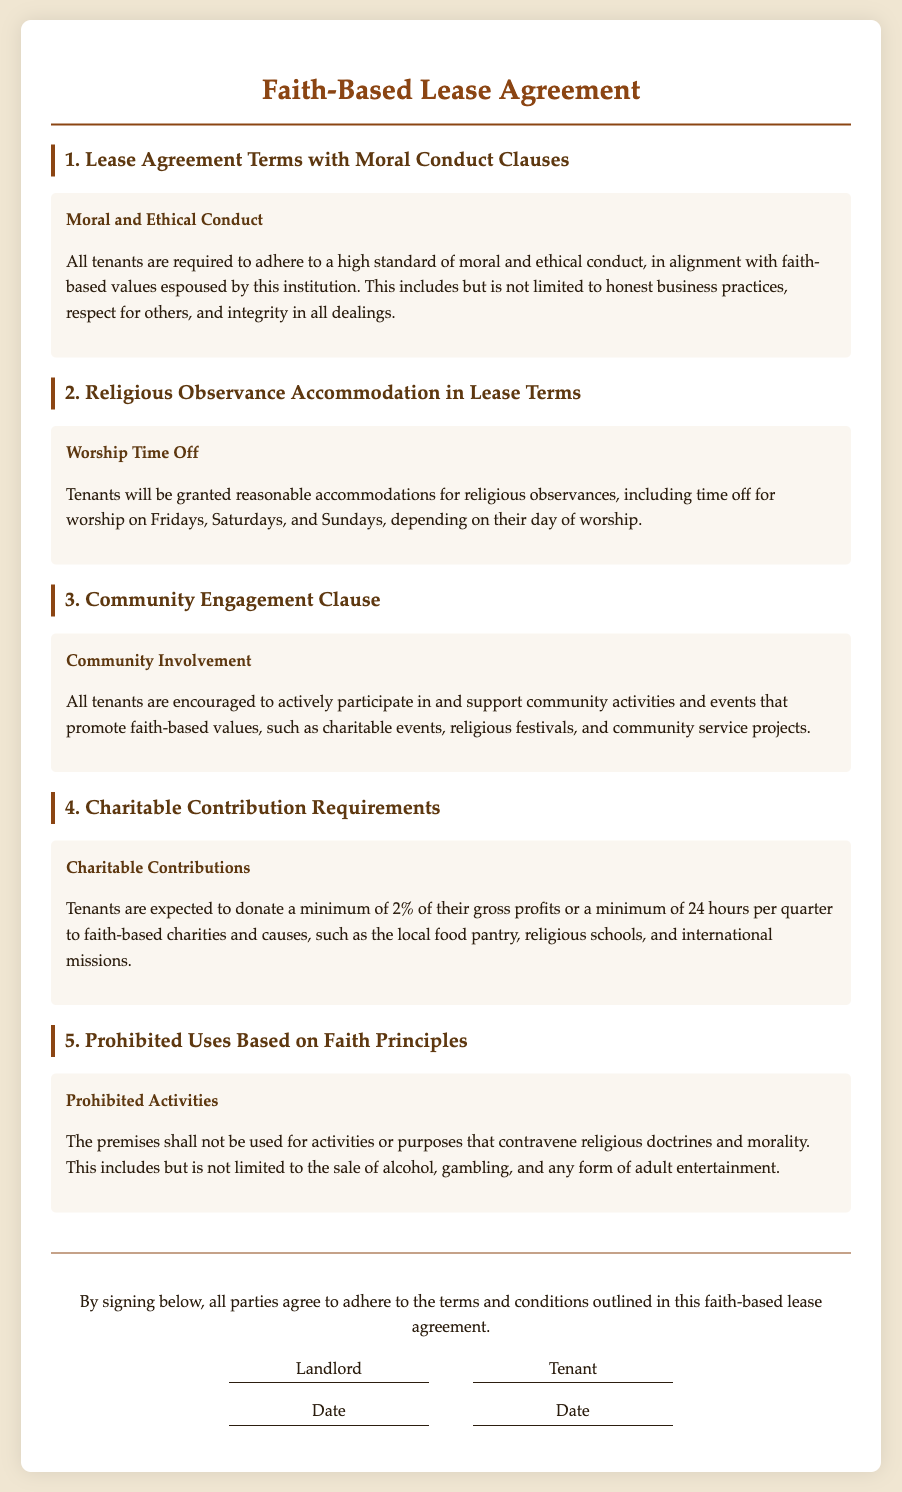What is the minimum donation percentage required from tenants? The document specifies that tenants are expected to donate a minimum of 2% of their gross profits or a minimum of 24 hours per quarter.
Answer: 2% What are the prohibited activities on the premises? The lease outlines that the premises shall not be used for activities that contravene religious doctrines and morality, which includes the sale of alcohol, gambling, and any form of adult entertainment.
Answer: Sale of alcohol, gambling, adult entertainment How many hours per quarter are tenants expected to contribute to charities? The document states that tenants must contribute a minimum of 24 hours per quarter to faith-based charities and causes.
Answer: 24 hours On which days are tenants granted time off for worship? The lease states that tenants will be granted reasonable accommodations for religious observances, including time off for worship on Fridays, Saturdays, and Sundays.
Answer: Fridays, Saturdays, Sundays What is the title of the clause discussing moral conduct? The clause detailing moral conduct is titled "Moral and Ethical Conduct."
Answer: Moral and Ethical Conduct How does the lease encourage community involvement? The lease encourages tenants to actively participate in and support community activities that promote faith-based values, such as charitable events and community service projects.
Answer: Active participation and support in community activities What is the overarching theme of the lease agreement? The lease agreement is focused on aligning with and promoting faith-based values through various clauses and requirements.
Answer: Faith-based values What is the purpose of the "Charitable Contributions" clause? This clause obligates tenants to donate a portion of their profits or time to faith-based charities and causes, ensuring support for such organizations.
Answer: To obligate donations to faith-based charities 